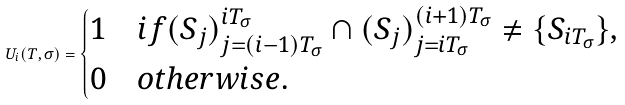<formula> <loc_0><loc_0><loc_500><loc_500>U _ { i } ( T , \sigma ) = \begin{cases} 1 & i f ( S _ { j } ) _ { j = ( i - 1 ) T _ { \sigma } } ^ { i T _ { \sigma } } \cap ( S _ { j } ) _ { j = i T _ { \sigma } } ^ { ( i + 1 ) T _ { \sigma } } \not = \{ S _ { i T _ { \sigma } } \} , \\ 0 & o t h e r w i s e . \end{cases}</formula> 